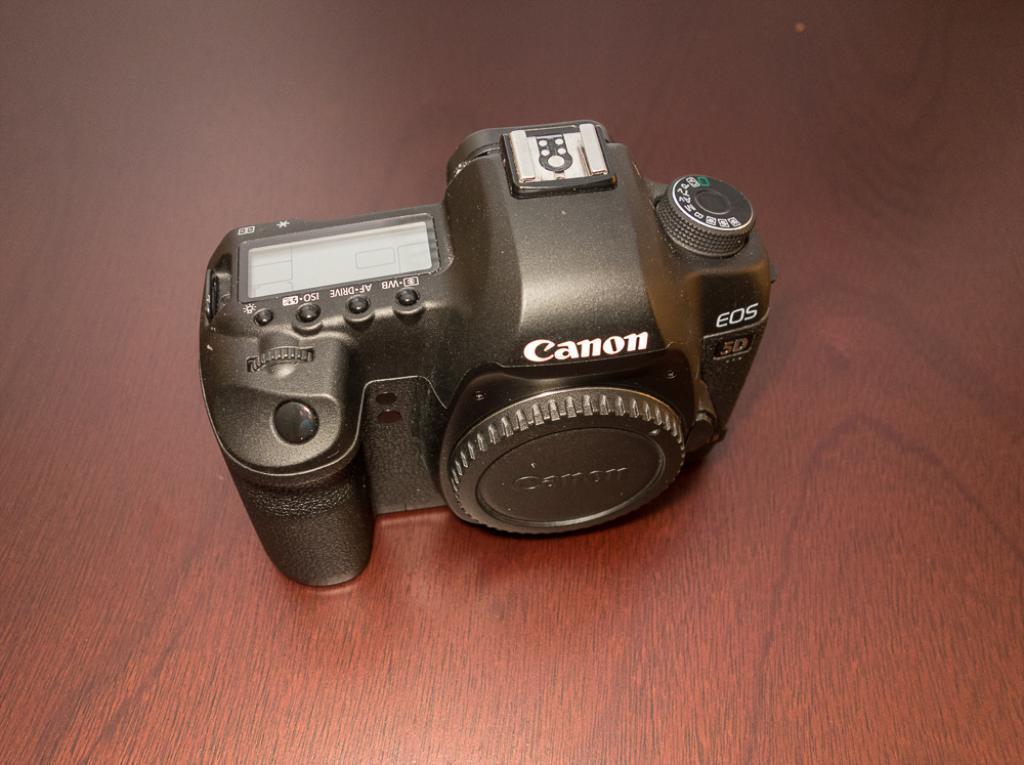How would you summarize this image in a sentence or two? In this picture we can observe a camera which is in black color. There is a lens cap fixed to this camera. This camera was placed on the brown color surface. 